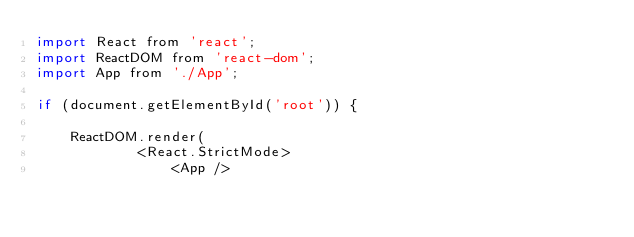Convert code to text. <code><loc_0><loc_0><loc_500><loc_500><_JavaScript_>import React from 'react';
import ReactDOM from 'react-dom';
import App from './App';

if (document.getElementById('root')) {

    ReactDOM.render(
            <React.StrictMode>
                <App /></code> 